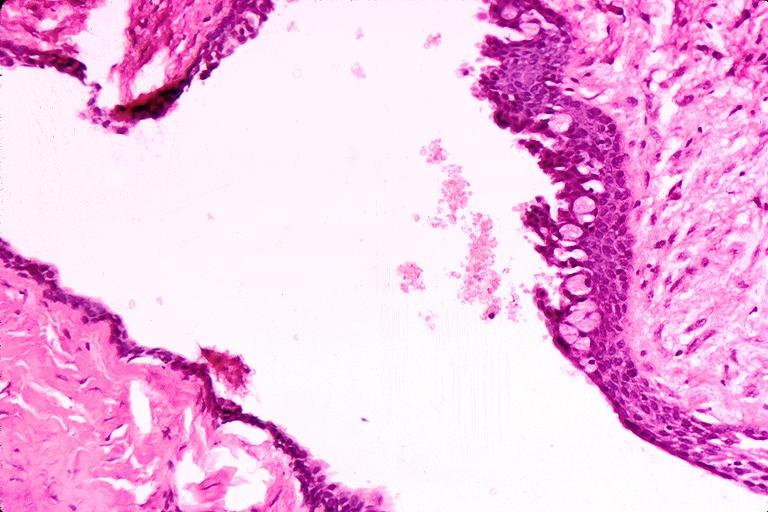s oral present?
Answer the question using a single word or phrase. Yes 